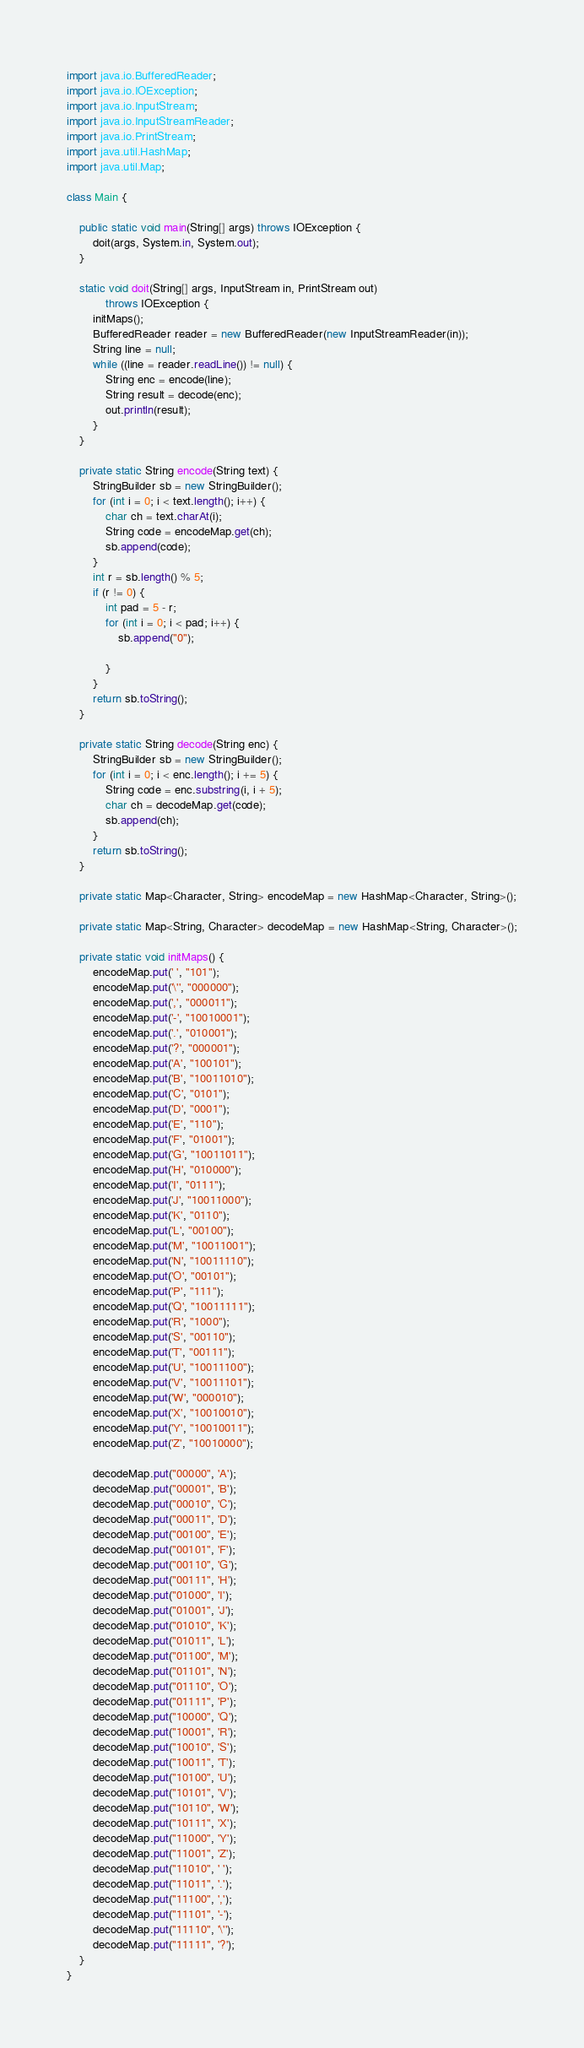Convert code to text. <code><loc_0><loc_0><loc_500><loc_500><_Java_>import java.io.BufferedReader;
import java.io.IOException;
import java.io.InputStream;
import java.io.InputStreamReader;
import java.io.PrintStream;
import java.util.HashMap;
import java.util.Map;

class Main {

    public static void main(String[] args) throws IOException {
        doit(args, System.in, System.out);
    }

    static void doit(String[] args, InputStream in, PrintStream out)
            throws IOException {
        initMaps();
        BufferedReader reader = new BufferedReader(new InputStreamReader(in));
        String line = null;
        while ((line = reader.readLine()) != null) {
            String enc = encode(line);
            String result = decode(enc);
            out.println(result);
        }
    }

    private static String encode(String text) {
        StringBuilder sb = new StringBuilder();
        for (int i = 0; i < text.length(); i++) {
            char ch = text.charAt(i);
            String code = encodeMap.get(ch);
            sb.append(code);
        }
        int r = sb.length() % 5;
        if (r != 0) {
            int pad = 5 - r;
            for (int i = 0; i < pad; i++) {
                sb.append("0");

            }
        }
        return sb.toString();
    }

    private static String decode(String enc) {
        StringBuilder sb = new StringBuilder();
        for (int i = 0; i < enc.length(); i += 5) {
            String code = enc.substring(i, i + 5);
            char ch = decodeMap.get(code);
            sb.append(ch);
        }
        return sb.toString();
    }

    private static Map<Character, String> encodeMap = new HashMap<Character, String>();

    private static Map<String, Character> decodeMap = new HashMap<String, Character>();

    private static void initMaps() {
        encodeMap.put(' ', "101");
        encodeMap.put('\'', "000000");
        encodeMap.put(',', "000011");
        encodeMap.put('-', "10010001");
        encodeMap.put('.', "010001");
        encodeMap.put('?', "000001");
        encodeMap.put('A', "100101");
        encodeMap.put('B', "10011010");
        encodeMap.put('C', "0101");
        encodeMap.put('D', "0001");
        encodeMap.put('E', "110");
        encodeMap.put('F', "01001");
        encodeMap.put('G', "10011011");
        encodeMap.put('H', "010000");
        encodeMap.put('I', "0111");
        encodeMap.put('J', "10011000");
        encodeMap.put('K', "0110");
        encodeMap.put('L', "00100");
        encodeMap.put('M', "10011001");
        encodeMap.put('N', "10011110");
        encodeMap.put('O', "00101");
        encodeMap.put('P', "111");
        encodeMap.put('Q', "10011111");
        encodeMap.put('R', "1000");
        encodeMap.put('S', "00110");
        encodeMap.put('T', "00111");
        encodeMap.put('U', "10011100");
        encodeMap.put('V', "10011101");
        encodeMap.put('W', "000010");
        encodeMap.put('X', "10010010");
        encodeMap.put('Y', "10010011");
        encodeMap.put('Z', "10010000");

        decodeMap.put("00000", 'A');
        decodeMap.put("00001", 'B');
        decodeMap.put("00010", 'C');
        decodeMap.put("00011", 'D');
        decodeMap.put("00100", 'E');
        decodeMap.put("00101", 'F');
        decodeMap.put("00110", 'G');
        decodeMap.put("00111", 'H');
        decodeMap.put("01000", 'I');
        decodeMap.put("01001", 'J');
        decodeMap.put("01010", 'K');
        decodeMap.put("01011", 'L');
        decodeMap.put("01100", 'M');
        decodeMap.put("01101", 'N');
        decodeMap.put("01110", 'O');
        decodeMap.put("01111", 'P');
        decodeMap.put("10000", 'Q');
        decodeMap.put("10001", 'R');
        decodeMap.put("10010", 'S');
        decodeMap.put("10011", 'T');
        decodeMap.put("10100", 'U');
        decodeMap.put("10101", 'V');
        decodeMap.put("10110", 'W');
        decodeMap.put("10111", 'X');
        decodeMap.put("11000", 'Y');
        decodeMap.put("11001", 'Z');
        decodeMap.put("11010", ' ');
        decodeMap.put("11011", '.');
        decodeMap.put("11100", ',');
        decodeMap.put("11101", '-');
        decodeMap.put("11110", '\'');
        decodeMap.put("11111", '?');
    }
}</code> 